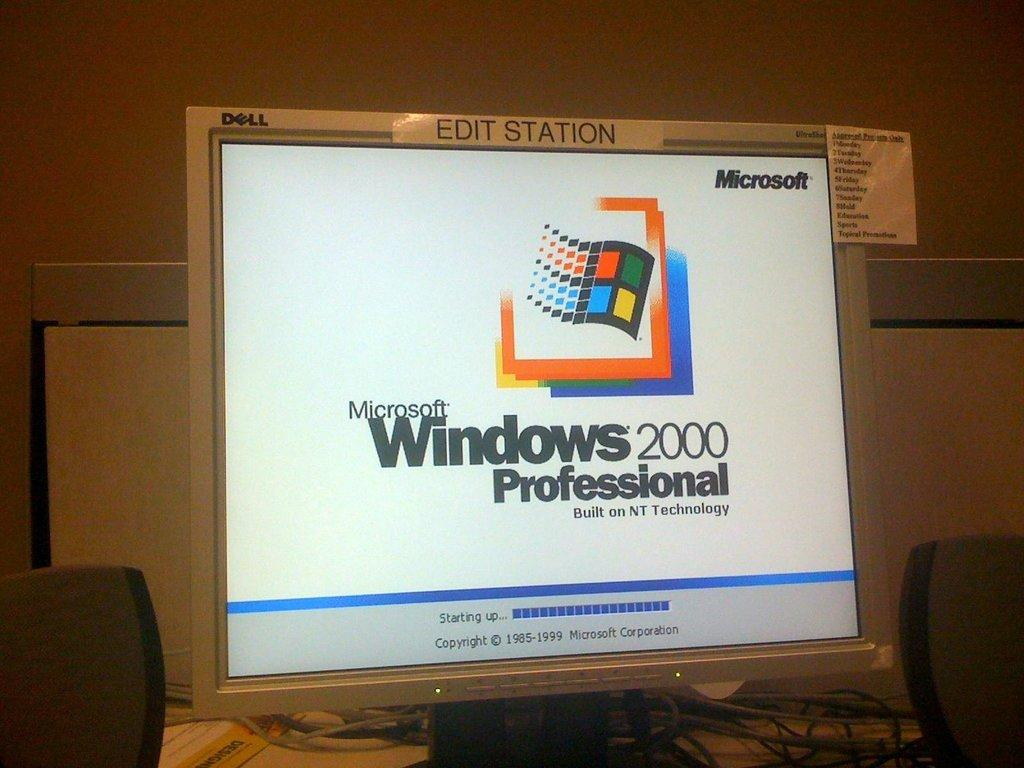Provide a one-sentence caption for the provided image. A computer is on with the display showing Microsoft Windows 2000 Professional with a logo. 